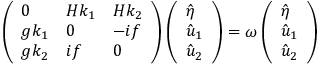Convert formula to latex. <formula><loc_0><loc_0><loc_500><loc_500>\left ( \begin{array} { l l l } { 0 } & { H k _ { 1 } } & { H k _ { 2 } } \\ { g k _ { 1 } } & { 0 } & { - i f } \\ { g k _ { 2 } } & { i f } & { 0 } \end{array} \right ) \left ( \begin{array} { l } { \hat { \eta } } \\ { \hat { u } _ { 1 } } \\ { \hat { u } _ { 2 } } \end{array} \right ) = \omega \left ( \begin{array} { l } { \hat { \eta } } \\ { \hat { u } _ { 1 } } \\ { \hat { u } _ { 2 } } \end{array} \right )</formula> 